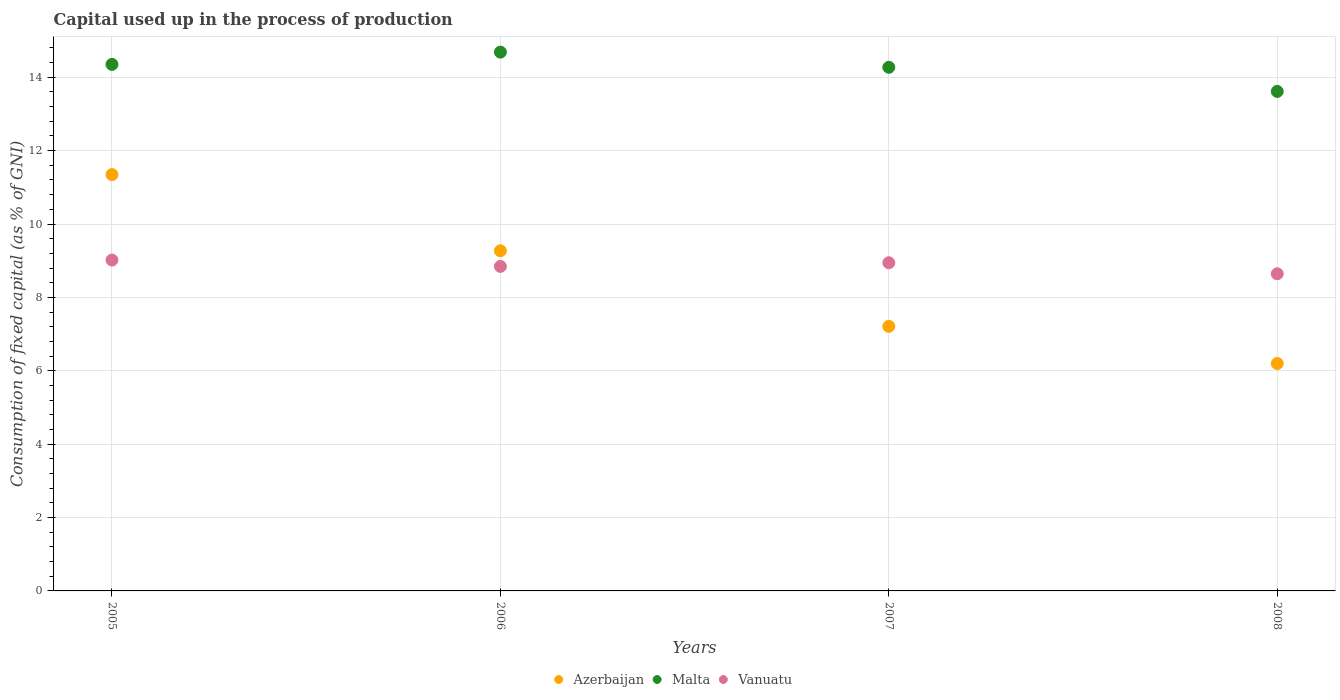How many different coloured dotlines are there?
Offer a very short reply. 3. What is the capital used up in the process of production in Vanuatu in 2007?
Offer a terse response. 8.94. Across all years, what is the maximum capital used up in the process of production in Malta?
Provide a succinct answer. 14.68. Across all years, what is the minimum capital used up in the process of production in Malta?
Provide a succinct answer. 13.61. In which year was the capital used up in the process of production in Malta minimum?
Make the answer very short. 2008. What is the total capital used up in the process of production in Azerbaijan in the graph?
Keep it short and to the point. 34.03. What is the difference between the capital used up in the process of production in Malta in 2005 and that in 2007?
Provide a short and direct response. 0.08. What is the difference between the capital used up in the process of production in Azerbaijan in 2008 and the capital used up in the process of production in Malta in 2007?
Keep it short and to the point. -8.07. What is the average capital used up in the process of production in Malta per year?
Provide a succinct answer. 14.23. In the year 2006, what is the difference between the capital used up in the process of production in Vanuatu and capital used up in the process of production in Malta?
Your response must be concise. -5.84. In how many years, is the capital used up in the process of production in Vanuatu greater than 6 %?
Keep it short and to the point. 4. What is the ratio of the capital used up in the process of production in Vanuatu in 2006 to that in 2008?
Ensure brevity in your answer.  1.02. Is the difference between the capital used up in the process of production in Vanuatu in 2007 and 2008 greater than the difference between the capital used up in the process of production in Malta in 2007 and 2008?
Keep it short and to the point. No. What is the difference between the highest and the second highest capital used up in the process of production in Azerbaijan?
Ensure brevity in your answer.  2.08. What is the difference between the highest and the lowest capital used up in the process of production in Azerbaijan?
Provide a succinct answer. 5.15. Is the sum of the capital used up in the process of production in Azerbaijan in 2005 and 2006 greater than the maximum capital used up in the process of production in Malta across all years?
Provide a succinct answer. Yes. Does the capital used up in the process of production in Malta monotonically increase over the years?
Your answer should be compact. No. How many years are there in the graph?
Give a very brief answer. 4. Are the values on the major ticks of Y-axis written in scientific E-notation?
Offer a terse response. No. Does the graph contain any zero values?
Offer a very short reply. No. Where does the legend appear in the graph?
Offer a very short reply. Bottom center. How many legend labels are there?
Offer a very short reply. 3. What is the title of the graph?
Provide a succinct answer. Capital used up in the process of production. What is the label or title of the Y-axis?
Your answer should be very brief. Consumption of fixed capital (as % of GNI). What is the Consumption of fixed capital (as % of GNI) of Azerbaijan in 2005?
Keep it short and to the point. 11.35. What is the Consumption of fixed capital (as % of GNI) of Malta in 2005?
Offer a very short reply. 14.35. What is the Consumption of fixed capital (as % of GNI) of Vanuatu in 2005?
Give a very brief answer. 9.02. What is the Consumption of fixed capital (as % of GNI) in Azerbaijan in 2006?
Ensure brevity in your answer.  9.27. What is the Consumption of fixed capital (as % of GNI) of Malta in 2006?
Give a very brief answer. 14.68. What is the Consumption of fixed capital (as % of GNI) in Vanuatu in 2006?
Ensure brevity in your answer.  8.84. What is the Consumption of fixed capital (as % of GNI) in Azerbaijan in 2007?
Offer a very short reply. 7.21. What is the Consumption of fixed capital (as % of GNI) of Malta in 2007?
Offer a very short reply. 14.27. What is the Consumption of fixed capital (as % of GNI) in Vanuatu in 2007?
Ensure brevity in your answer.  8.94. What is the Consumption of fixed capital (as % of GNI) of Azerbaijan in 2008?
Ensure brevity in your answer.  6.2. What is the Consumption of fixed capital (as % of GNI) of Malta in 2008?
Your response must be concise. 13.61. What is the Consumption of fixed capital (as % of GNI) in Vanuatu in 2008?
Your response must be concise. 8.64. Across all years, what is the maximum Consumption of fixed capital (as % of GNI) of Azerbaijan?
Provide a succinct answer. 11.35. Across all years, what is the maximum Consumption of fixed capital (as % of GNI) in Malta?
Make the answer very short. 14.68. Across all years, what is the maximum Consumption of fixed capital (as % of GNI) in Vanuatu?
Your answer should be very brief. 9.02. Across all years, what is the minimum Consumption of fixed capital (as % of GNI) in Azerbaijan?
Make the answer very short. 6.2. Across all years, what is the minimum Consumption of fixed capital (as % of GNI) of Malta?
Offer a very short reply. 13.61. Across all years, what is the minimum Consumption of fixed capital (as % of GNI) in Vanuatu?
Your answer should be very brief. 8.64. What is the total Consumption of fixed capital (as % of GNI) of Azerbaijan in the graph?
Offer a terse response. 34.02. What is the total Consumption of fixed capital (as % of GNI) of Malta in the graph?
Provide a succinct answer. 56.92. What is the total Consumption of fixed capital (as % of GNI) of Vanuatu in the graph?
Provide a short and direct response. 35.45. What is the difference between the Consumption of fixed capital (as % of GNI) in Azerbaijan in 2005 and that in 2006?
Give a very brief answer. 2.08. What is the difference between the Consumption of fixed capital (as % of GNI) of Malta in 2005 and that in 2006?
Your answer should be compact. -0.33. What is the difference between the Consumption of fixed capital (as % of GNI) in Vanuatu in 2005 and that in 2006?
Your response must be concise. 0.17. What is the difference between the Consumption of fixed capital (as % of GNI) in Azerbaijan in 2005 and that in 2007?
Your answer should be very brief. 4.14. What is the difference between the Consumption of fixed capital (as % of GNI) in Malta in 2005 and that in 2007?
Make the answer very short. 0.08. What is the difference between the Consumption of fixed capital (as % of GNI) in Vanuatu in 2005 and that in 2007?
Give a very brief answer. 0.07. What is the difference between the Consumption of fixed capital (as % of GNI) in Azerbaijan in 2005 and that in 2008?
Give a very brief answer. 5.15. What is the difference between the Consumption of fixed capital (as % of GNI) of Malta in 2005 and that in 2008?
Your answer should be compact. 0.74. What is the difference between the Consumption of fixed capital (as % of GNI) of Vanuatu in 2005 and that in 2008?
Your response must be concise. 0.37. What is the difference between the Consumption of fixed capital (as % of GNI) of Azerbaijan in 2006 and that in 2007?
Provide a short and direct response. 2.06. What is the difference between the Consumption of fixed capital (as % of GNI) of Malta in 2006 and that in 2007?
Provide a short and direct response. 0.41. What is the difference between the Consumption of fixed capital (as % of GNI) of Vanuatu in 2006 and that in 2007?
Your answer should be compact. -0.1. What is the difference between the Consumption of fixed capital (as % of GNI) of Azerbaijan in 2006 and that in 2008?
Keep it short and to the point. 3.07. What is the difference between the Consumption of fixed capital (as % of GNI) in Malta in 2006 and that in 2008?
Make the answer very short. 1.07. What is the difference between the Consumption of fixed capital (as % of GNI) in Vanuatu in 2006 and that in 2008?
Provide a succinct answer. 0.2. What is the difference between the Consumption of fixed capital (as % of GNI) in Azerbaijan in 2007 and that in 2008?
Offer a terse response. 1.01. What is the difference between the Consumption of fixed capital (as % of GNI) of Malta in 2007 and that in 2008?
Provide a short and direct response. 0.66. What is the difference between the Consumption of fixed capital (as % of GNI) of Vanuatu in 2007 and that in 2008?
Your answer should be compact. 0.3. What is the difference between the Consumption of fixed capital (as % of GNI) in Azerbaijan in 2005 and the Consumption of fixed capital (as % of GNI) in Malta in 2006?
Make the answer very short. -3.34. What is the difference between the Consumption of fixed capital (as % of GNI) in Azerbaijan in 2005 and the Consumption of fixed capital (as % of GNI) in Vanuatu in 2006?
Ensure brevity in your answer.  2.5. What is the difference between the Consumption of fixed capital (as % of GNI) of Malta in 2005 and the Consumption of fixed capital (as % of GNI) of Vanuatu in 2006?
Ensure brevity in your answer.  5.51. What is the difference between the Consumption of fixed capital (as % of GNI) in Azerbaijan in 2005 and the Consumption of fixed capital (as % of GNI) in Malta in 2007?
Make the answer very short. -2.92. What is the difference between the Consumption of fixed capital (as % of GNI) of Azerbaijan in 2005 and the Consumption of fixed capital (as % of GNI) of Vanuatu in 2007?
Provide a short and direct response. 2.4. What is the difference between the Consumption of fixed capital (as % of GNI) in Malta in 2005 and the Consumption of fixed capital (as % of GNI) in Vanuatu in 2007?
Keep it short and to the point. 5.41. What is the difference between the Consumption of fixed capital (as % of GNI) in Azerbaijan in 2005 and the Consumption of fixed capital (as % of GNI) in Malta in 2008?
Provide a succinct answer. -2.27. What is the difference between the Consumption of fixed capital (as % of GNI) in Azerbaijan in 2005 and the Consumption of fixed capital (as % of GNI) in Vanuatu in 2008?
Provide a short and direct response. 2.7. What is the difference between the Consumption of fixed capital (as % of GNI) of Malta in 2005 and the Consumption of fixed capital (as % of GNI) of Vanuatu in 2008?
Your answer should be very brief. 5.71. What is the difference between the Consumption of fixed capital (as % of GNI) in Azerbaijan in 2006 and the Consumption of fixed capital (as % of GNI) in Malta in 2007?
Provide a short and direct response. -5. What is the difference between the Consumption of fixed capital (as % of GNI) in Azerbaijan in 2006 and the Consumption of fixed capital (as % of GNI) in Vanuatu in 2007?
Offer a terse response. 0.33. What is the difference between the Consumption of fixed capital (as % of GNI) in Malta in 2006 and the Consumption of fixed capital (as % of GNI) in Vanuatu in 2007?
Your answer should be compact. 5.74. What is the difference between the Consumption of fixed capital (as % of GNI) of Azerbaijan in 2006 and the Consumption of fixed capital (as % of GNI) of Malta in 2008?
Provide a succinct answer. -4.34. What is the difference between the Consumption of fixed capital (as % of GNI) in Azerbaijan in 2006 and the Consumption of fixed capital (as % of GNI) in Vanuatu in 2008?
Make the answer very short. 0.63. What is the difference between the Consumption of fixed capital (as % of GNI) of Malta in 2006 and the Consumption of fixed capital (as % of GNI) of Vanuatu in 2008?
Your answer should be very brief. 6.04. What is the difference between the Consumption of fixed capital (as % of GNI) of Azerbaijan in 2007 and the Consumption of fixed capital (as % of GNI) of Malta in 2008?
Offer a terse response. -6.4. What is the difference between the Consumption of fixed capital (as % of GNI) of Azerbaijan in 2007 and the Consumption of fixed capital (as % of GNI) of Vanuatu in 2008?
Provide a short and direct response. -1.43. What is the difference between the Consumption of fixed capital (as % of GNI) of Malta in 2007 and the Consumption of fixed capital (as % of GNI) of Vanuatu in 2008?
Give a very brief answer. 5.63. What is the average Consumption of fixed capital (as % of GNI) of Azerbaijan per year?
Keep it short and to the point. 8.51. What is the average Consumption of fixed capital (as % of GNI) of Malta per year?
Offer a very short reply. 14.23. What is the average Consumption of fixed capital (as % of GNI) of Vanuatu per year?
Your answer should be very brief. 8.86. In the year 2005, what is the difference between the Consumption of fixed capital (as % of GNI) in Azerbaijan and Consumption of fixed capital (as % of GNI) in Malta?
Offer a terse response. -3. In the year 2005, what is the difference between the Consumption of fixed capital (as % of GNI) in Azerbaijan and Consumption of fixed capital (as % of GNI) in Vanuatu?
Your answer should be very brief. 2.33. In the year 2005, what is the difference between the Consumption of fixed capital (as % of GNI) of Malta and Consumption of fixed capital (as % of GNI) of Vanuatu?
Provide a short and direct response. 5.33. In the year 2006, what is the difference between the Consumption of fixed capital (as % of GNI) in Azerbaijan and Consumption of fixed capital (as % of GNI) in Malta?
Make the answer very short. -5.41. In the year 2006, what is the difference between the Consumption of fixed capital (as % of GNI) in Azerbaijan and Consumption of fixed capital (as % of GNI) in Vanuatu?
Offer a terse response. 0.43. In the year 2006, what is the difference between the Consumption of fixed capital (as % of GNI) in Malta and Consumption of fixed capital (as % of GNI) in Vanuatu?
Your response must be concise. 5.84. In the year 2007, what is the difference between the Consumption of fixed capital (as % of GNI) in Azerbaijan and Consumption of fixed capital (as % of GNI) in Malta?
Give a very brief answer. -7.06. In the year 2007, what is the difference between the Consumption of fixed capital (as % of GNI) of Azerbaijan and Consumption of fixed capital (as % of GNI) of Vanuatu?
Your response must be concise. -1.73. In the year 2007, what is the difference between the Consumption of fixed capital (as % of GNI) of Malta and Consumption of fixed capital (as % of GNI) of Vanuatu?
Offer a terse response. 5.33. In the year 2008, what is the difference between the Consumption of fixed capital (as % of GNI) of Azerbaijan and Consumption of fixed capital (as % of GNI) of Malta?
Your answer should be very brief. -7.41. In the year 2008, what is the difference between the Consumption of fixed capital (as % of GNI) of Azerbaijan and Consumption of fixed capital (as % of GNI) of Vanuatu?
Your response must be concise. -2.44. In the year 2008, what is the difference between the Consumption of fixed capital (as % of GNI) of Malta and Consumption of fixed capital (as % of GNI) of Vanuatu?
Offer a very short reply. 4.97. What is the ratio of the Consumption of fixed capital (as % of GNI) in Azerbaijan in 2005 to that in 2006?
Provide a short and direct response. 1.22. What is the ratio of the Consumption of fixed capital (as % of GNI) of Malta in 2005 to that in 2006?
Offer a very short reply. 0.98. What is the ratio of the Consumption of fixed capital (as % of GNI) in Vanuatu in 2005 to that in 2006?
Offer a terse response. 1.02. What is the ratio of the Consumption of fixed capital (as % of GNI) of Azerbaijan in 2005 to that in 2007?
Your answer should be compact. 1.57. What is the ratio of the Consumption of fixed capital (as % of GNI) of Vanuatu in 2005 to that in 2007?
Give a very brief answer. 1.01. What is the ratio of the Consumption of fixed capital (as % of GNI) of Azerbaijan in 2005 to that in 2008?
Provide a succinct answer. 1.83. What is the ratio of the Consumption of fixed capital (as % of GNI) of Malta in 2005 to that in 2008?
Your response must be concise. 1.05. What is the ratio of the Consumption of fixed capital (as % of GNI) in Vanuatu in 2005 to that in 2008?
Ensure brevity in your answer.  1.04. What is the ratio of the Consumption of fixed capital (as % of GNI) of Azerbaijan in 2006 to that in 2007?
Your answer should be very brief. 1.29. What is the ratio of the Consumption of fixed capital (as % of GNI) of Malta in 2006 to that in 2007?
Provide a short and direct response. 1.03. What is the ratio of the Consumption of fixed capital (as % of GNI) of Azerbaijan in 2006 to that in 2008?
Offer a terse response. 1.5. What is the ratio of the Consumption of fixed capital (as % of GNI) of Malta in 2006 to that in 2008?
Your answer should be compact. 1.08. What is the ratio of the Consumption of fixed capital (as % of GNI) in Vanuatu in 2006 to that in 2008?
Provide a succinct answer. 1.02. What is the ratio of the Consumption of fixed capital (as % of GNI) in Azerbaijan in 2007 to that in 2008?
Give a very brief answer. 1.16. What is the ratio of the Consumption of fixed capital (as % of GNI) in Malta in 2007 to that in 2008?
Keep it short and to the point. 1.05. What is the ratio of the Consumption of fixed capital (as % of GNI) of Vanuatu in 2007 to that in 2008?
Your answer should be compact. 1.03. What is the difference between the highest and the second highest Consumption of fixed capital (as % of GNI) of Azerbaijan?
Provide a succinct answer. 2.08. What is the difference between the highest and the second highest Consumption of fixed capital (as % of GNI) of Malta?
Keep it short and to the point. 0.33. What is the difference between the highest and the second highest Consumption of fixed capital (as % of GNI) of Vanuatu?
Your answer should be compact. 0.07. What is the difference between the highest and the lowest Consumption of fixed capital (as % of GNI) of Azerbaijan?
Your response must be concise. 5.15. What is the difference between the highest and the lowest Consumption of fixed capital (as % of GNI) in Malta?
Give a very brief answer. 1.07. What is the difference between the highest and the lowest Consumption of fixed capital (as % of GNI) of Vanuatu?
Your answer should be very brief. 0.37. 